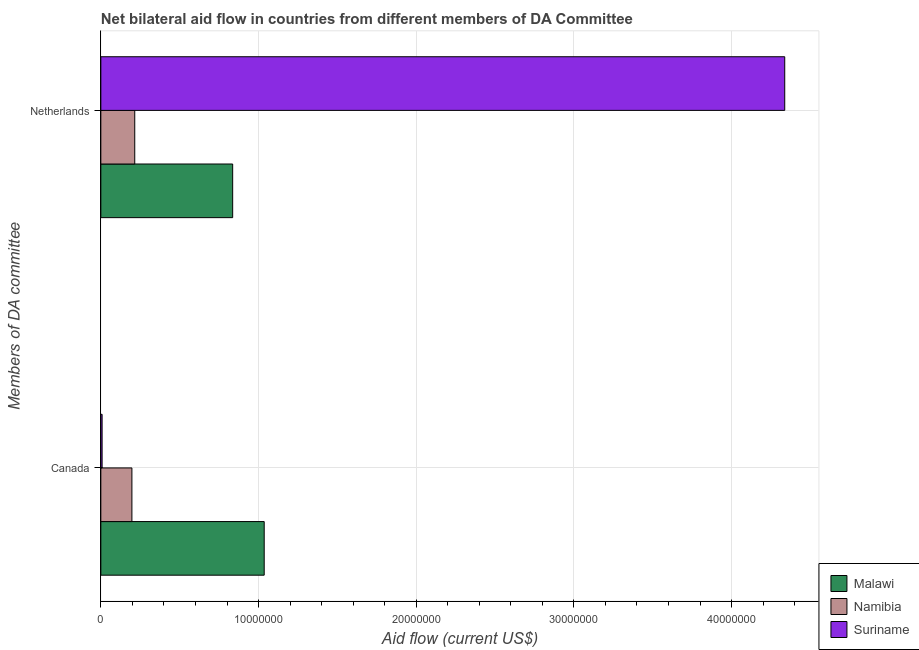Are the number of bars on each tick of the Y-axis equal?
Provide a succinct answer. Yes. What is the label of the 2nd group of bars from the top?
Provide a short and direct response. Canada. What is the amount of aid given by netherlands in Malawi?
Ensure brevity in your answer.  8.36e+06. Across all countries, what is the maximum amount of aid given by canada?
Make the answer very short. 1.04e+07. Across all countries, what is the minimum amount of aid given by canada?
Offer a very short reply. 8.00e+04. In which country was the amount of aid given by canada maximum?
Give a very brief answer. Malawi. In which country was the amount of aid given by canada minimum?
Offer a very short reply. Suriname. What is the total amount of aid given by canada in the graph?
Keep it short and to the point. 1.24e+07. What is the difference between the amount of aid given by netherlands in Namibia and that in Malawi?
Your answer should be compact. -6.21e+06. What is the difference between the amount of aid given by netherlands in Namibia and the amount of aid given by canada in Malawi?
Give a very brief answer. -8.21e+06. What is the average amount of aid given by canada per country?
Your answer should be very brief. 4.14e+06. What is the difference between the amount of aid given by canada and amount of aid given by netherlands in Malawi?
Ensure brevity in your answer.  2.00e+06. What is the ratio of the amount of aid given by canada in Namibia to that in Suriname?
Make the answer very short. 24.62. Is the amount of aid given by netherlands in Malawi less than that in Suriname?
Your answer should be compact. Yes. What does the 1st bar from the top in Netherlands represents?
Give a very brief answer. Suriname. What does the 2nd bar from the bottom in Canada represents?
Your response must be concise. Namibia. Are all the bars in the graph horizontal?
Your answer should be very brief. Yes. How many countries are there in the graph?
Your answer should be very brief. 3. Where does the legend appear in the graph?
Offer a very short reply. Bottom right. What is the title of the graph?
Give a very brief answer. Net bilateral aid flow in countries from different members of DA Committee. Does "Palau" appear as one of the legend labels in the graph?
Give a very brief answer. No. What is the label or title of the X-axis?
Offer a very short reply. Aid flow (current US$). What is the label or title of the Y-axis?
Offer a terse response. Members of DA committee. What is the Aid flow (current US$) in Malawi in Canada?
Provide a succinct answer. 1.04e+07. What is the Aid flow (current US$) of Namibia in Canada?
Provide a short and direct response. 1.97e+06. What is the Aid flow (current US$) of Suriname in Canada?
Ensure brevity in your answer.  8.00e+04. What is the Aid flow (current US$) of Malawi in Netherlands?
Make the answer very short. 8.36e+06. What is the Aid flow (current US$) of Namibia in Netherlands?
Make the answer very short. 2.15e+06. What is the Aid flow (current US$) in Suriname in Netherlands?
Provide a succinct answer. 4.34e+07. Across all Members of DA committee, what is the maximum Aid flow (current US$) in Malawi?
Keep it short and to the point. 1.04e+07. Across all Members of DA committee, what is the maximum Aid flow (current US$) of Namibia?
Your answer should be compact. 2.15e+06. Across all Members of DA committee, what is the maximum Aid flow (current US$) in Suriname?
Your response must be concise. 4.34e+07. Across all Members of DA committee, what is the minimum Aid flow (current US$) of Malawi?
Your response must be concise. 8.36e+06. Across all Members of DA committee, what is the minimum Aid flow (current US$) in Namibia?
Provide a succinct answer. 1.97e+06. Across all Members of DA committee, what is the minimum Aid flow (current US$) in Suriname?
Offer a terse response. 8.00e+04. What is the total Aid flow (current US$) of Malawi in the graph?
Offer a very short reply. 1.87e+07. What is the total Aid flow (current US$) in Namibia in the graph?
Keep it short and to the point. 4.12e+06. What is the total Aid flow (current US$) in Suriname in the graph?
Your answer should be very brief. 4.34e+07. What is the difference between the Aid flow (current US$) in Malawi in Canada and that in Netherlands?
Give a very brief answer. 2.00e+06. What is the difference between the Aid flow (current US$) in Namibia in Canada and that in Netherlands?
Make the answer very short. -1.80e+05. What is the difference between the Aid flow (current US$) of Suriname in Canada and that in Netherlands?
Your response must be concise. -4.33e+07. What is the difference between the Aid flow (current US$) of Malawi in Canada and the Aid flow (current US$) of Namibia in Netherlands?
Provide a short and direct response. 8.21e+06. What is the difference between the Aid flow (current US$) of Malawi in Canada and the Aid flow (current US$) of Suriname in Netherlands?
Your response must be concise. -3.30e+07. What is the difference between the Aid flow (current US$) in Namibia in Canada and the Aid flow (current US$) in Suriname in Netherlands?
Provide a succinct answer. -4.14e+07. What is the average Aid flow (current US$) in Malawi per Members of DA committee?
Your response must be concise. 9.36e+06. What is the average Aid flow (current US$) of Namibia per Members of DA committee?
Your answer should be very brief. 2.06e+06. What is the average Aid flow (current US$) of Suriname per Members of DA committee?
Offer a terse response. 2.17e+07. What is the difference between the Aid flow (current US$) of Malawi and Aid flow (current US$) of Namibia in Canada?
Provide a succinct answer. 8.39e+06. What is the difference between the Aid flow (current US$) of Malawi and Aid flow (current US$) of Suriname in Canada?
Provide a succinct answer. 1.03e+07. What is the difference between the Aid flow (current US$) in Namibia and Aid flow (current US$) in Suriname in Canada?
Keep it short and to the point. 1.89e+06. What is the difference between the Aid flow (current US$) in Malawi and Aid flow (current US$) in Namibia in Netherlands?
Offer a terse response. 6.21e+06. What is the difference between the Aid flow (current US$) of Malawi and Aid flow (current US$) of Suriname in Netherlands?
Give a very brief answer. -3.50e+07. What is the difference between the Aid flow (current US$) in Namibia and Aid flow (current US$) in Suriname in Netherlands?
Your response must be concise. -4.12e+07. What is the ratio of the Aid flow (current US$) in Malawi in Canada to that in Netherlands?
Your answer should be compact. 1.24. What is the ratio of the Aid flow (current US$) in Namibia in Canada to that in Netherlands?
Keep it short and to the point. 0.92. What is the ratio of the Aid flow (current US$) of Suriname in Canada to that in Netherlands?
Provide a short and direct response. 0. What is the difference between the highest and the second highest Aid flow (current US$) in Namibia?
Offer a very short reply. 1.80e+05. What is the difference between the highest and the second highest Aid flow (current US$) in Suriname?
Ensure brevity in your answer.  4.33e+07. What is the difference between the highest and the lowest Aid flow (current US$) of Namibia?
Your answer should be compact. 1.80e+05. What is the difference between the highest and the lowest Aid flow (current US$) in Suriname?
Provide a succinct answer. 4.33e+07. 